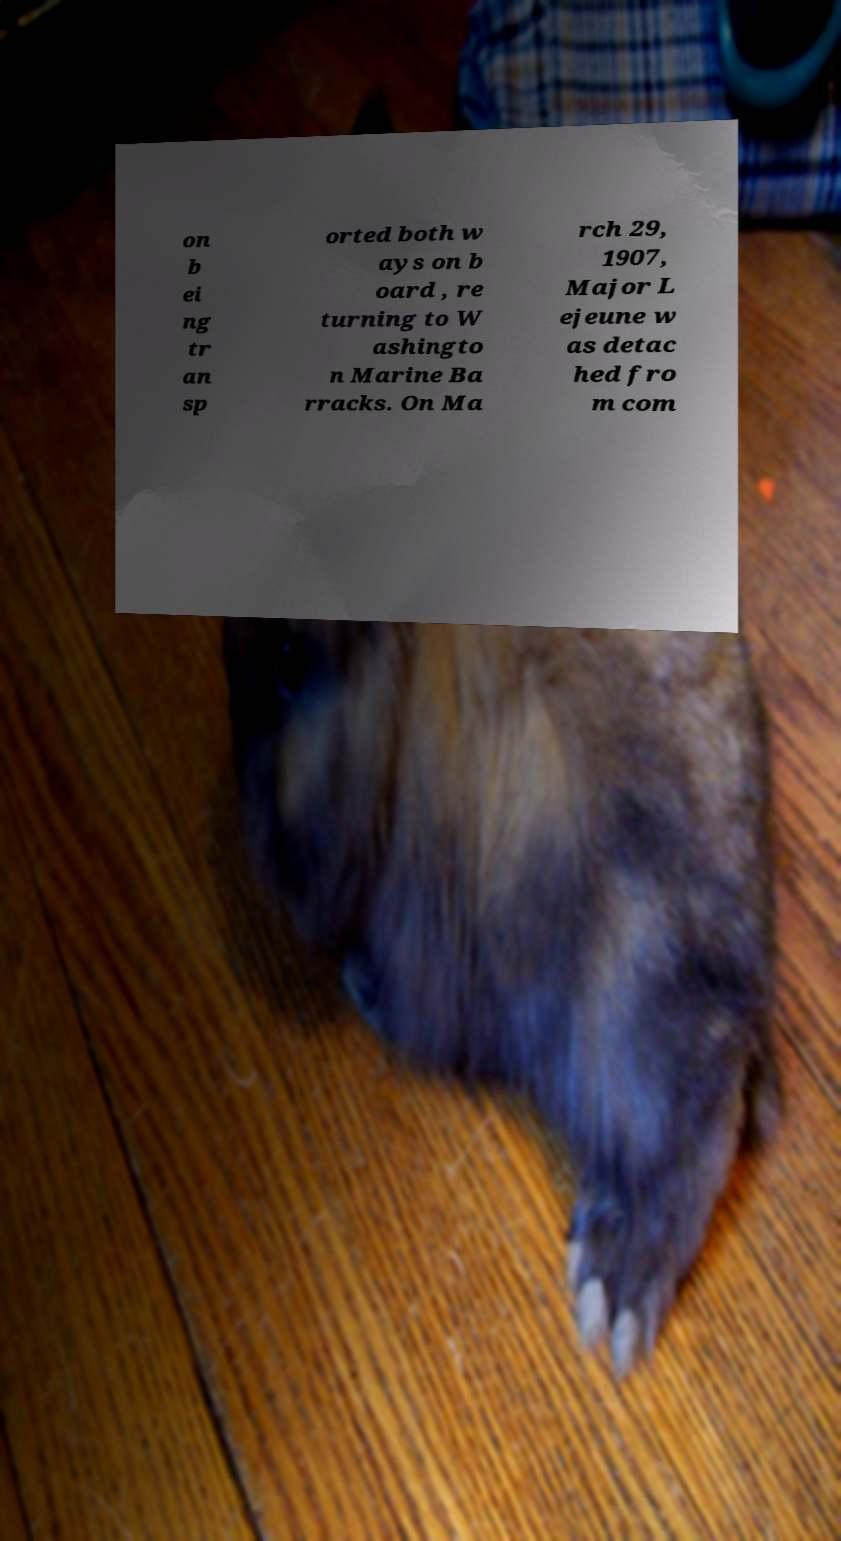What messages or text are displayed in this image? I need them in a readable, typed format. on b ei ng tr an sp orted both w ays on b oard , re turning to W ashingto n Marine Ba rracks. On Ma rch 29, 1907, Major L ejeune w as detac hed fro m com 